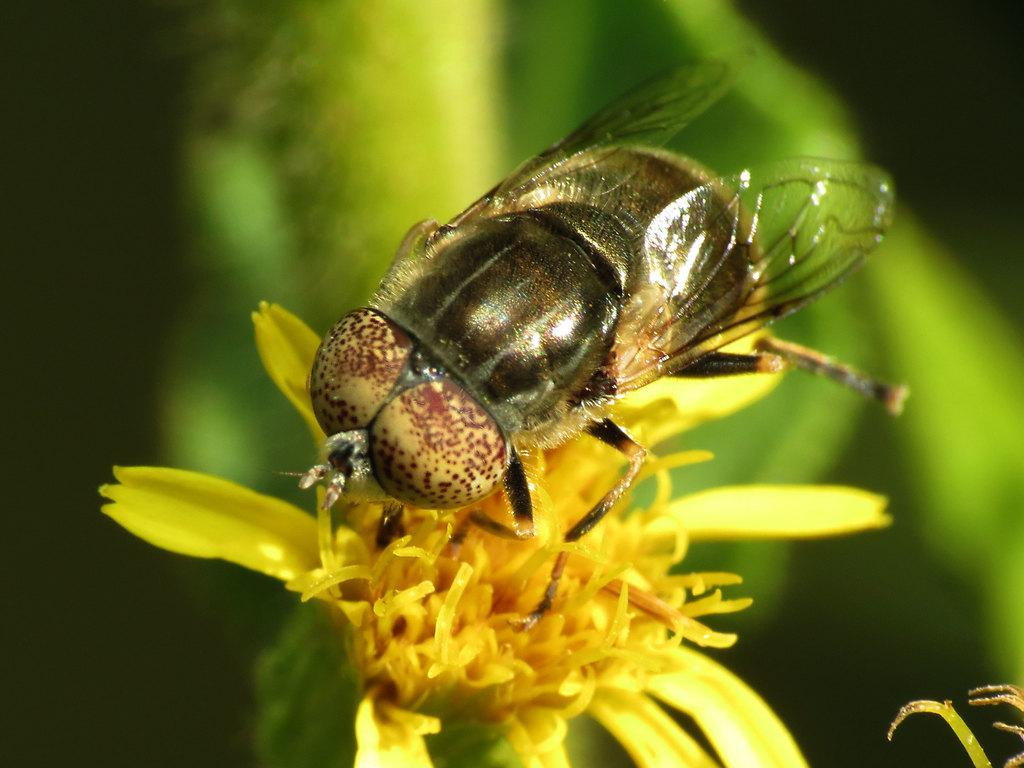What type of insect is in the image? There is a honey bee in the image. What is the honey bee doing in the image? The honey bee is sitting on a yellow flower. Can you describe the background of the image? The background of the image is blurred. What type of sugar is the rat eating in the image? There is no rat or sugar present in the image; it features a honey bee sitting on a yellow flower. 